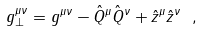Convert formula to latex. <formula><loc_0><loc_0><loc_500><loc_500>g _ { \perp } ^ { \mu \nu } = g ^ { \mu \nu } - \hat { Q } ^ { \mu } \hat { Q } ^ { \nu } + \hat { z } ^ { \mu } \hat { z } ^ { \nu } \ ,</formula> 